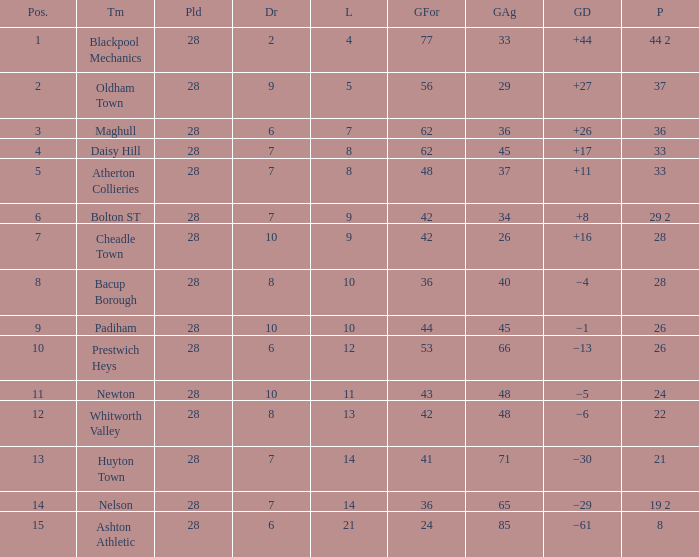What is the highest goals entry with drawn larger than 6 and goals against 85? None. 